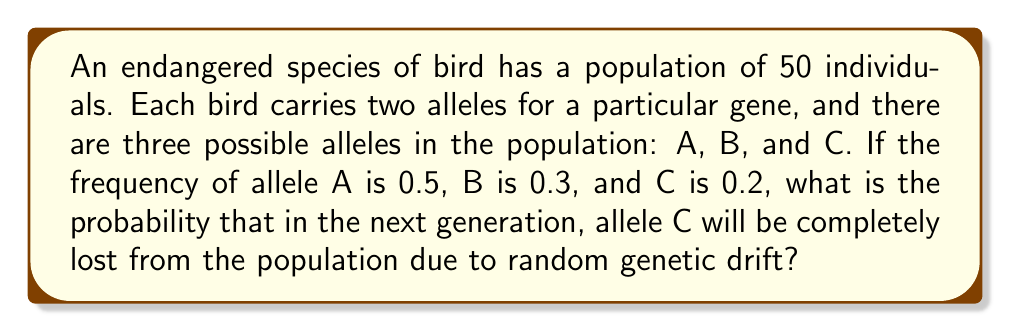Give your solution to this math problem. To solve this problem, we need to follow these steps:

1. Calculate the number of alleles in the population:
   Total alleles = 50 birds × 2 alleles per bird = 100 alleles

2. Calculate the number of C alleles:
   Number of C alleles = 100 × 0.2 = 20 alleles

3. The probability of losing allele C is the same as the probability that none of the 100 alleles in the next generation will be C.

4. For each allele in the next generation:
   Probability of not being C = 1 - 0.2 = 0.8

5. For all 100 alleles to not be C, we need this to happen 100 times independently:
   Probability of all alleles not being C = $0.8^{100}$

6. Calculate this probability:
   $$P(\text{losing C}) = 0.8^{100} \approx 2.0373 \times 10^{-10}$$

This extremely small probability indicates that while genetic drift can cause allele loss in small populations, it's unlikely to happen in a single generation for this population size and allele frequency.
Answer: $2.0373 \times 10^{-10}$ 